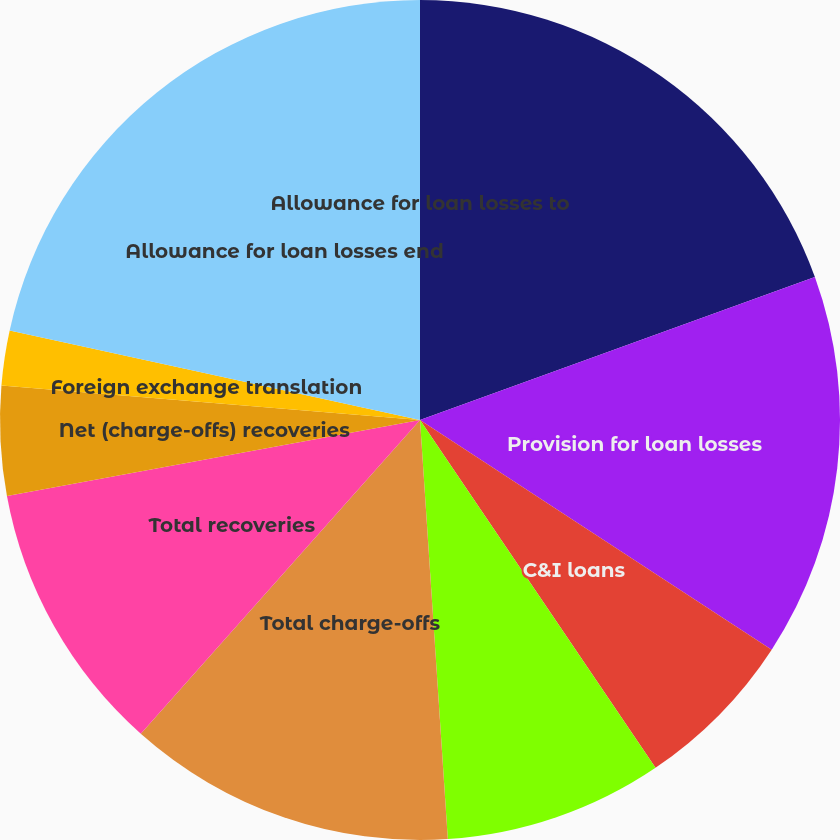<chart> <loc_0><loc_0><loc_500><loc_500><pie_chart><fcel>Allowance for loan losses<fcel>Provision for loan losses<fcel>C&I loans<fcel>Residential mortgage loans<fcel>Total charge-offs<fcel>Total recoveries<fcel>Net (charge-offs) recoveries<fcel>Foreign exchange translation<fcel>Allowance for loan losses end<fcel>Allowance for loan losses to<nl><fcel>19.47%<fcel>14.74%<fcel>6.32%<fcel>8.42%<fcel>12.63%<fcel>10.53%<fcel>4.21%<fcel>2.11%<fcel>21.58%<fcel>0.0%<nl></chart> 